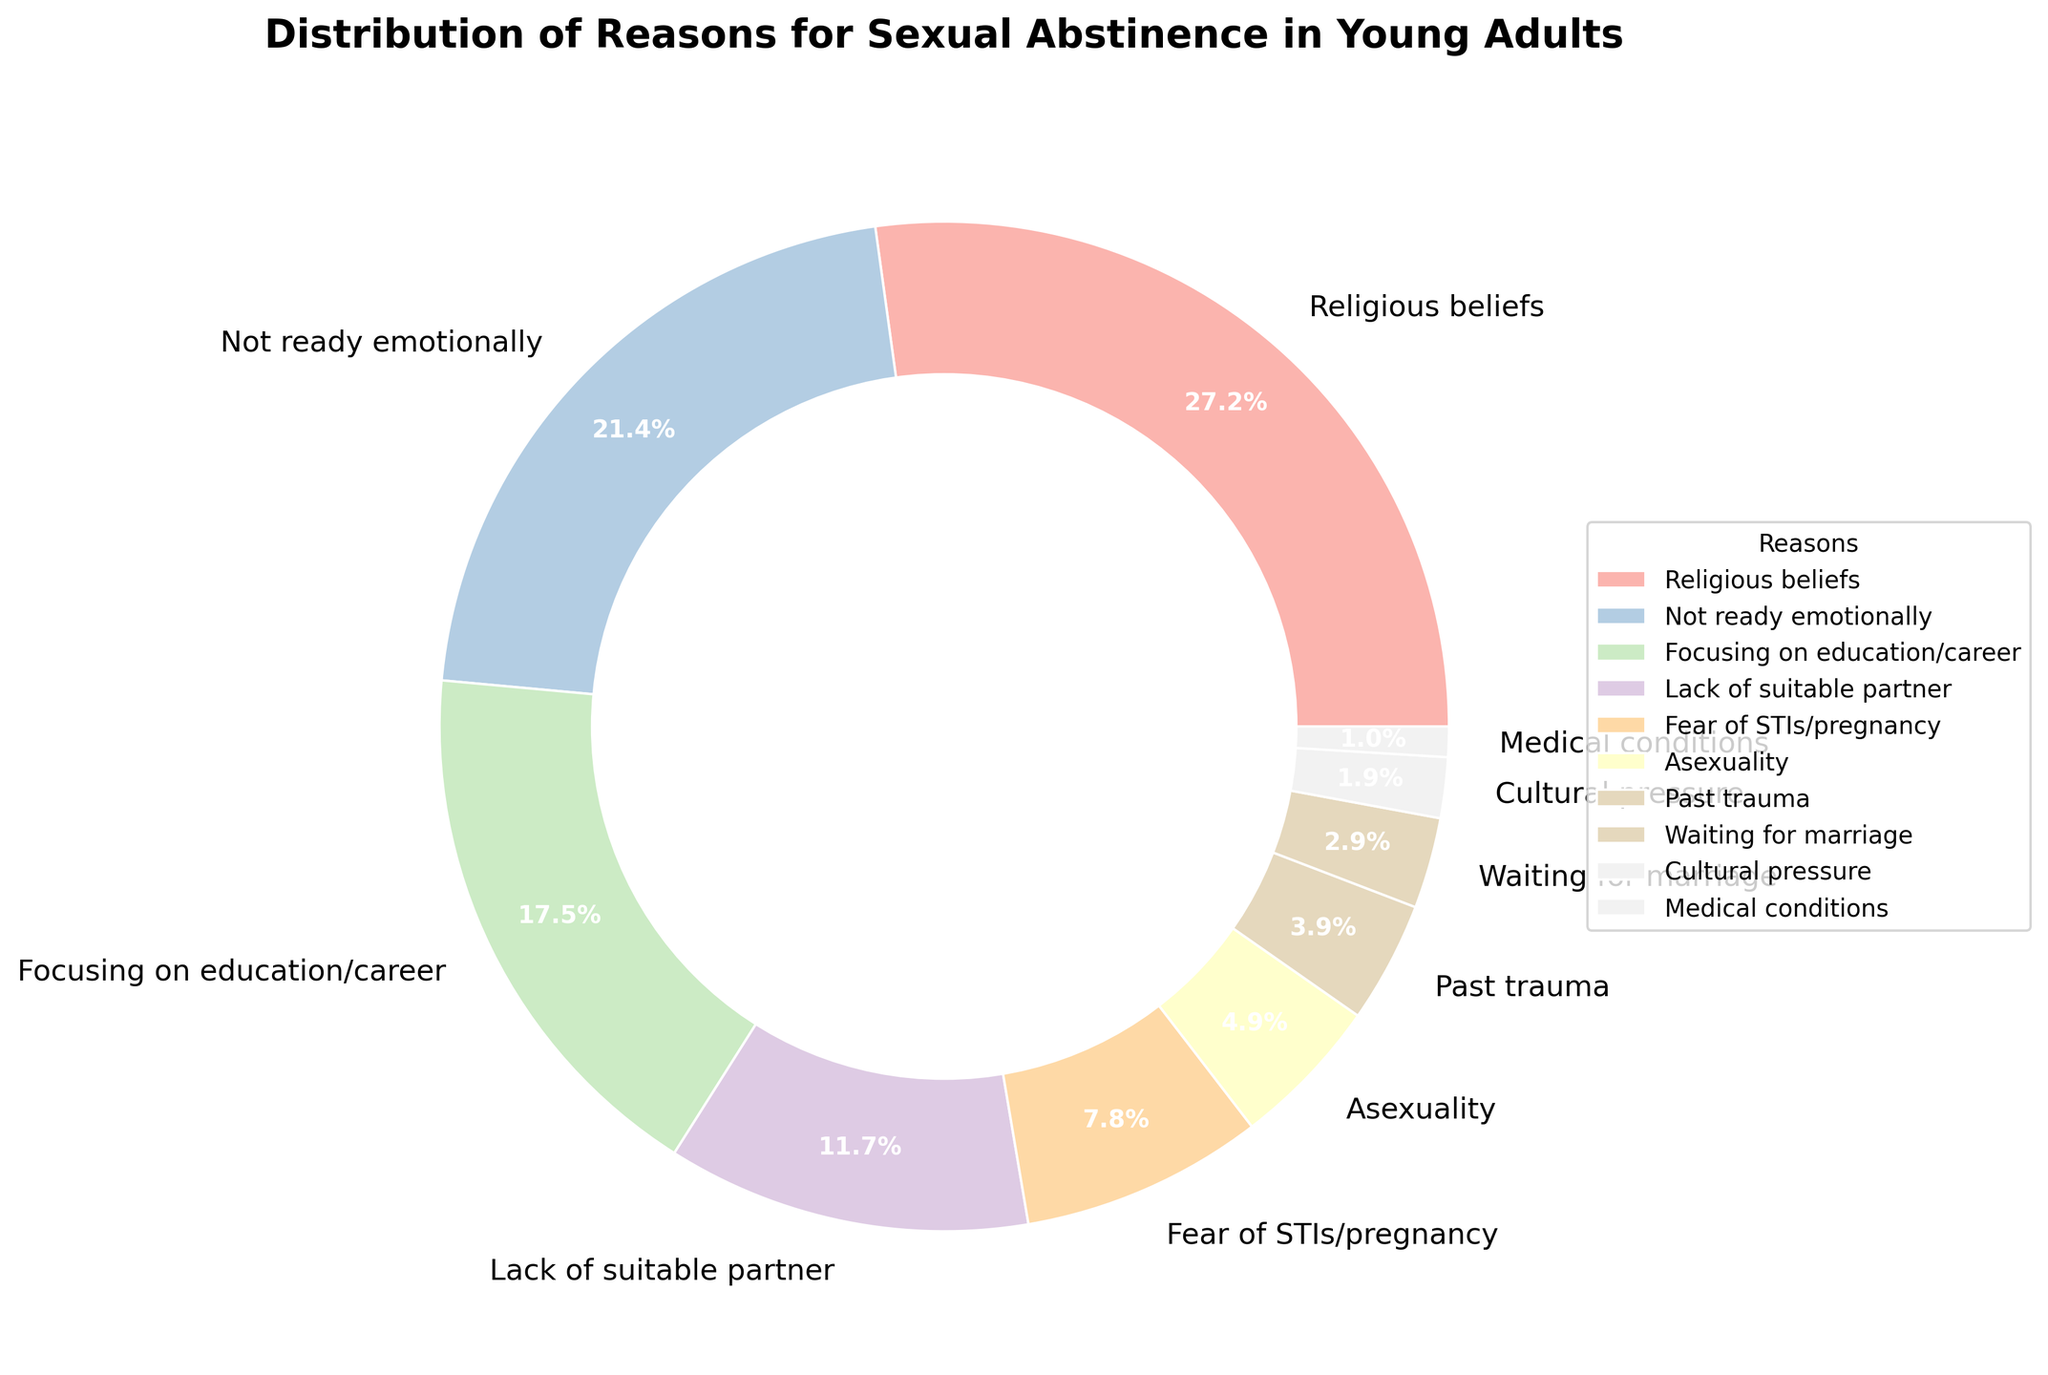What's the most common reason for sexual abstinence in young adults? The figure shows the reasons for sexual abstinence with their corresponding percentages. The reason with the highest percentage is the most common reason.
Answer: Religious beliefs Which reason has a higher percentage: "Not ready emotionally" or "Focusing on education/career"? To determine which reason has a higher percentage, compare the provided percentages for each reason. "Not ready emotionally" has 22%, and "Focusing on education/career" has 18%.
Answer: Not ready emotionally What's the combined percentage for "Asexuality" and "Past trauma"? To find the combined percentage, add the percentages for both reasons. Asexuality has 5% and Past trauma has 4%, so the combined percentage is 5% + 4% = 9%.
Answer: 9% Which are the least common reasons with percentages less than or equal to 5%? Observe the percentages and select those that are less than or equal to 5%. These are Asexuality (5%), Past trauma (4%), Waiting for marriage (3%), Cultural pressure (2%), and Medical conditions (1%).
Answer: Asexuality, Past trauma, Waiting for marriage, Cultural pressure, Medical conditions What percentage of young adults cite "Fear of STIs/pregnancy" as a reason for their abstinence? Look at the percentage associated with "Fear of STIs/pregnancy" in the figure.
Answer: 8% Is the percentage of young adults who abstain due to "Lack of suitable partner" greater than those who abstain due to "Fear of STIs/pregnancy"? Compare the percentages for "Lack of suitable partner" and "Fear of STIs/pregnancy".  "Lack of suitable partner" has 12% and "Fear of STIs/pregnancy" has 8%.
Answer: Yes How does the percentage of those abstaining due to "Focusing on education/career" compare to those abstaining due to "Religious beliefs"? Compare the percentage for "Focusing on education/career" (18%) with that for "Religious beliefs" (28%).
Answer: Less than What visual attribute makes it easier to distinguish between different sections of the pie chart? The chart uses different colors for each section, making it easier to distinguish between the reasons. Additionally, the sections are labeled with percentages.
Answer: Different colors and labeled percentages 